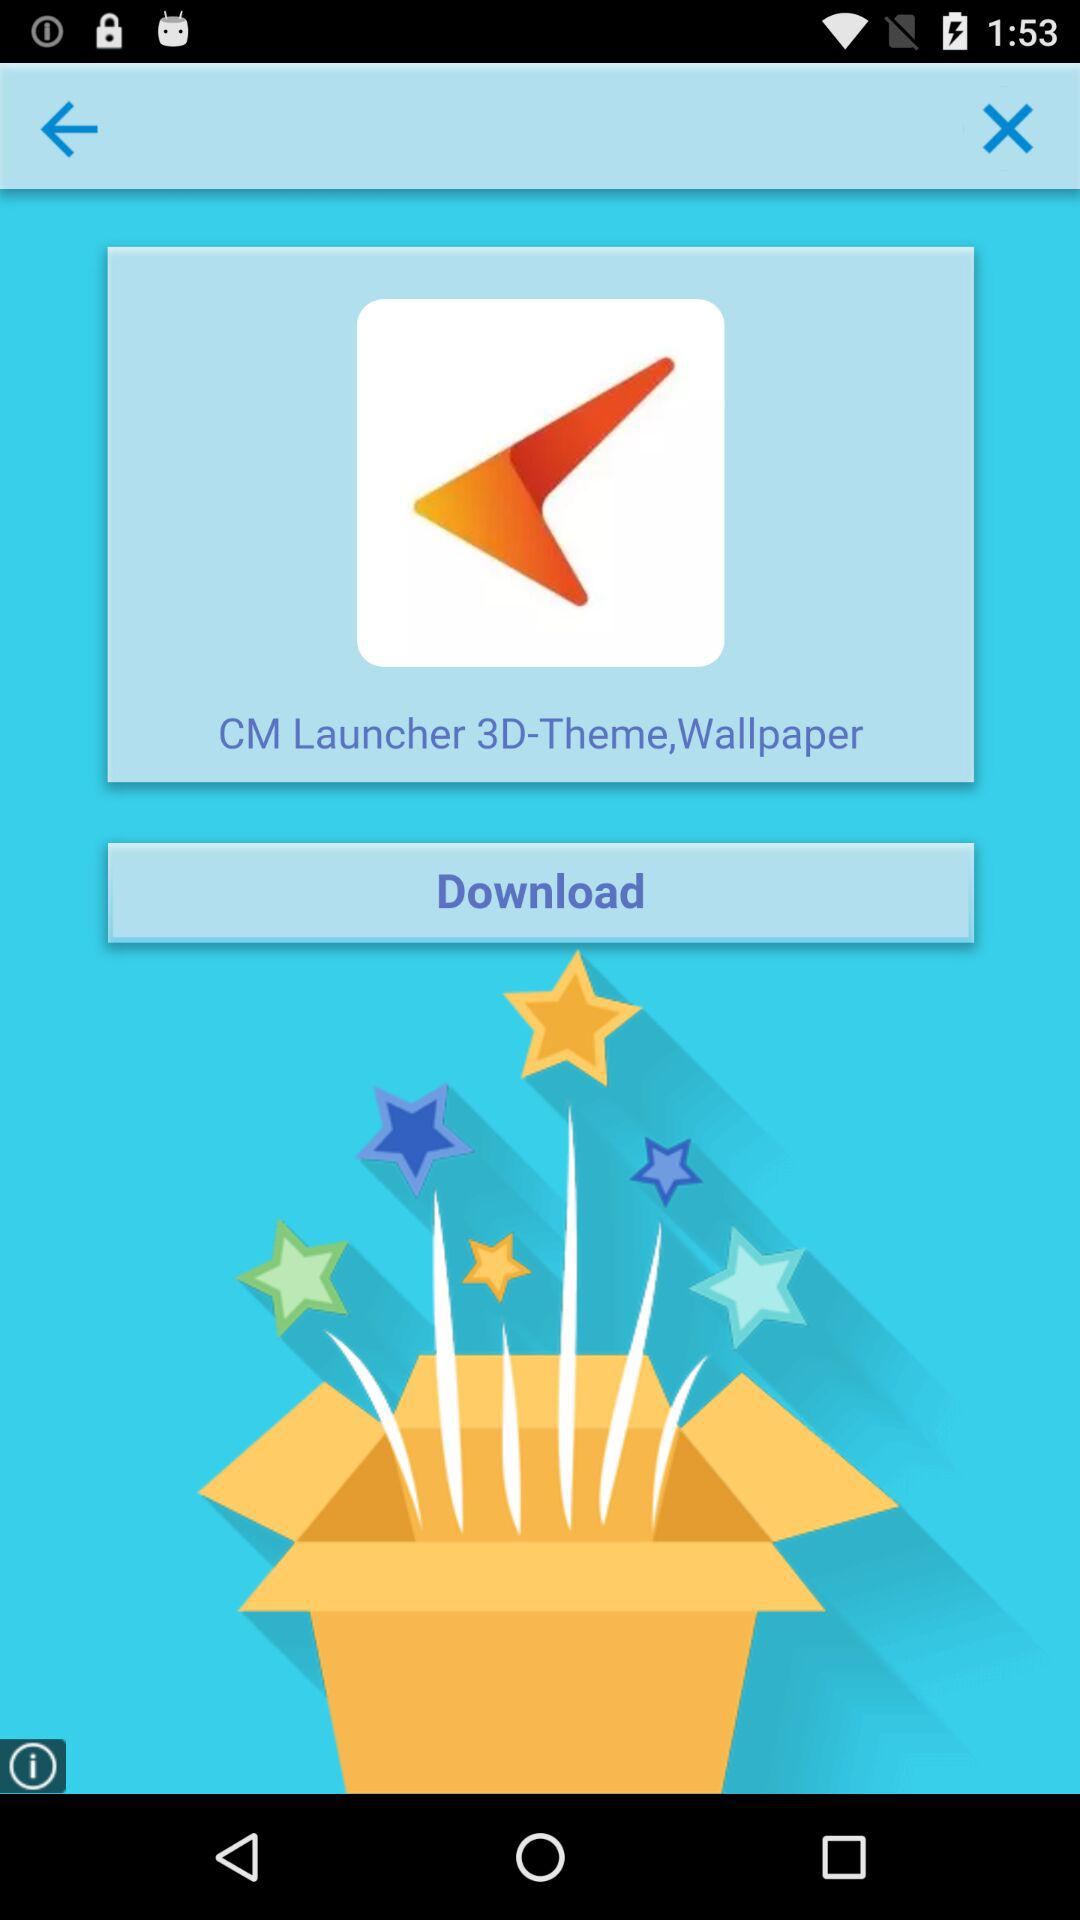What is the application name? The application name is "CM Launcher 3D-Theme, Wallpaper". 